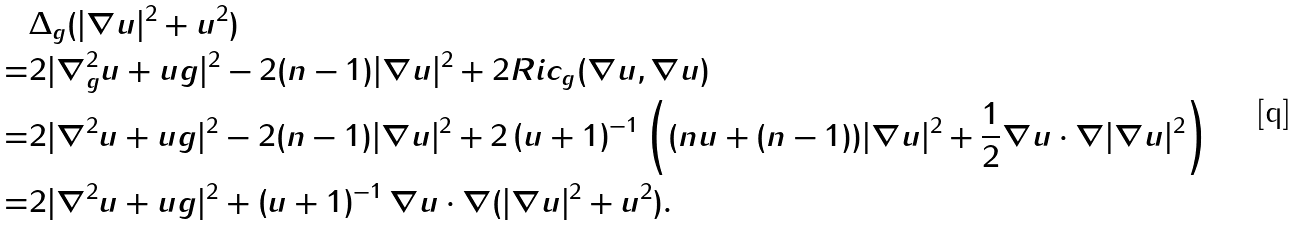Convert formula to latex. <formula><loc_0><loc_0><loc_500><loc_500>& \Delta _ { g } ( | \nabla u | ^ { 2 } + u ^ { 2 } ) \\ = & 2 | \nabla _ { g } ^ { 2 } u + u g | ^ { 2 } - 2 ( n - 1 ) | \nabla u | ^ { 2 } + 2 R i c _ { g } ( \nabla u , \nabla u ) \\ = & 2 | \nabla ^ { 2 } u + u g | ^ { 2 } - 2 ( n - 1 ) | \nabla u | ^ { 2 } + 2 \left ( u + 1 \right ) ^ { - 1 } \left ( ( n u + ( n - 1 ) ) | \nabla u | ^ { 2 } + \frac { 1 } { 2 } \nabla u \cdot \nabla | \nabla u | ^ { 2 } \right ) \\ = & 2 | \nabla ^ { 2 } u + u g | ^ { 2 } + \left ( u + 1 \right ) ^ { - 1 } \nabla u \cdot \nabla ( | \nabla u | ^ { 2 } + u ^ { 2 } ) .</formula> 